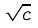<formula> <loc_0><loc_0><loc_500><loc_500>\sqrt { c }</formula> 